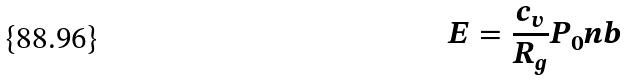Convert formula to latex. <formula><loc_0><loc_0><loc_500><loc_500>E = \frac { c _ { v } } { R _ { g } } P _ { 0 } n b</formula> 